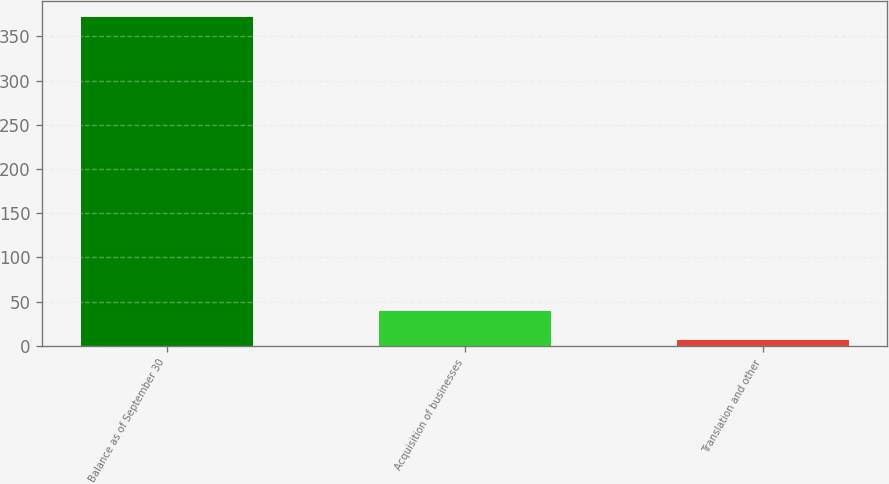<chart> <loc_0><loc_0><loc_500><loc_500><bar_chart><fcel>Balance as of September 30<fcel>Acquisition of businesses<fcel>Translation and other<nl><fcel>371.78<fcel>39.54<fcel>6.7<nl></chart> 